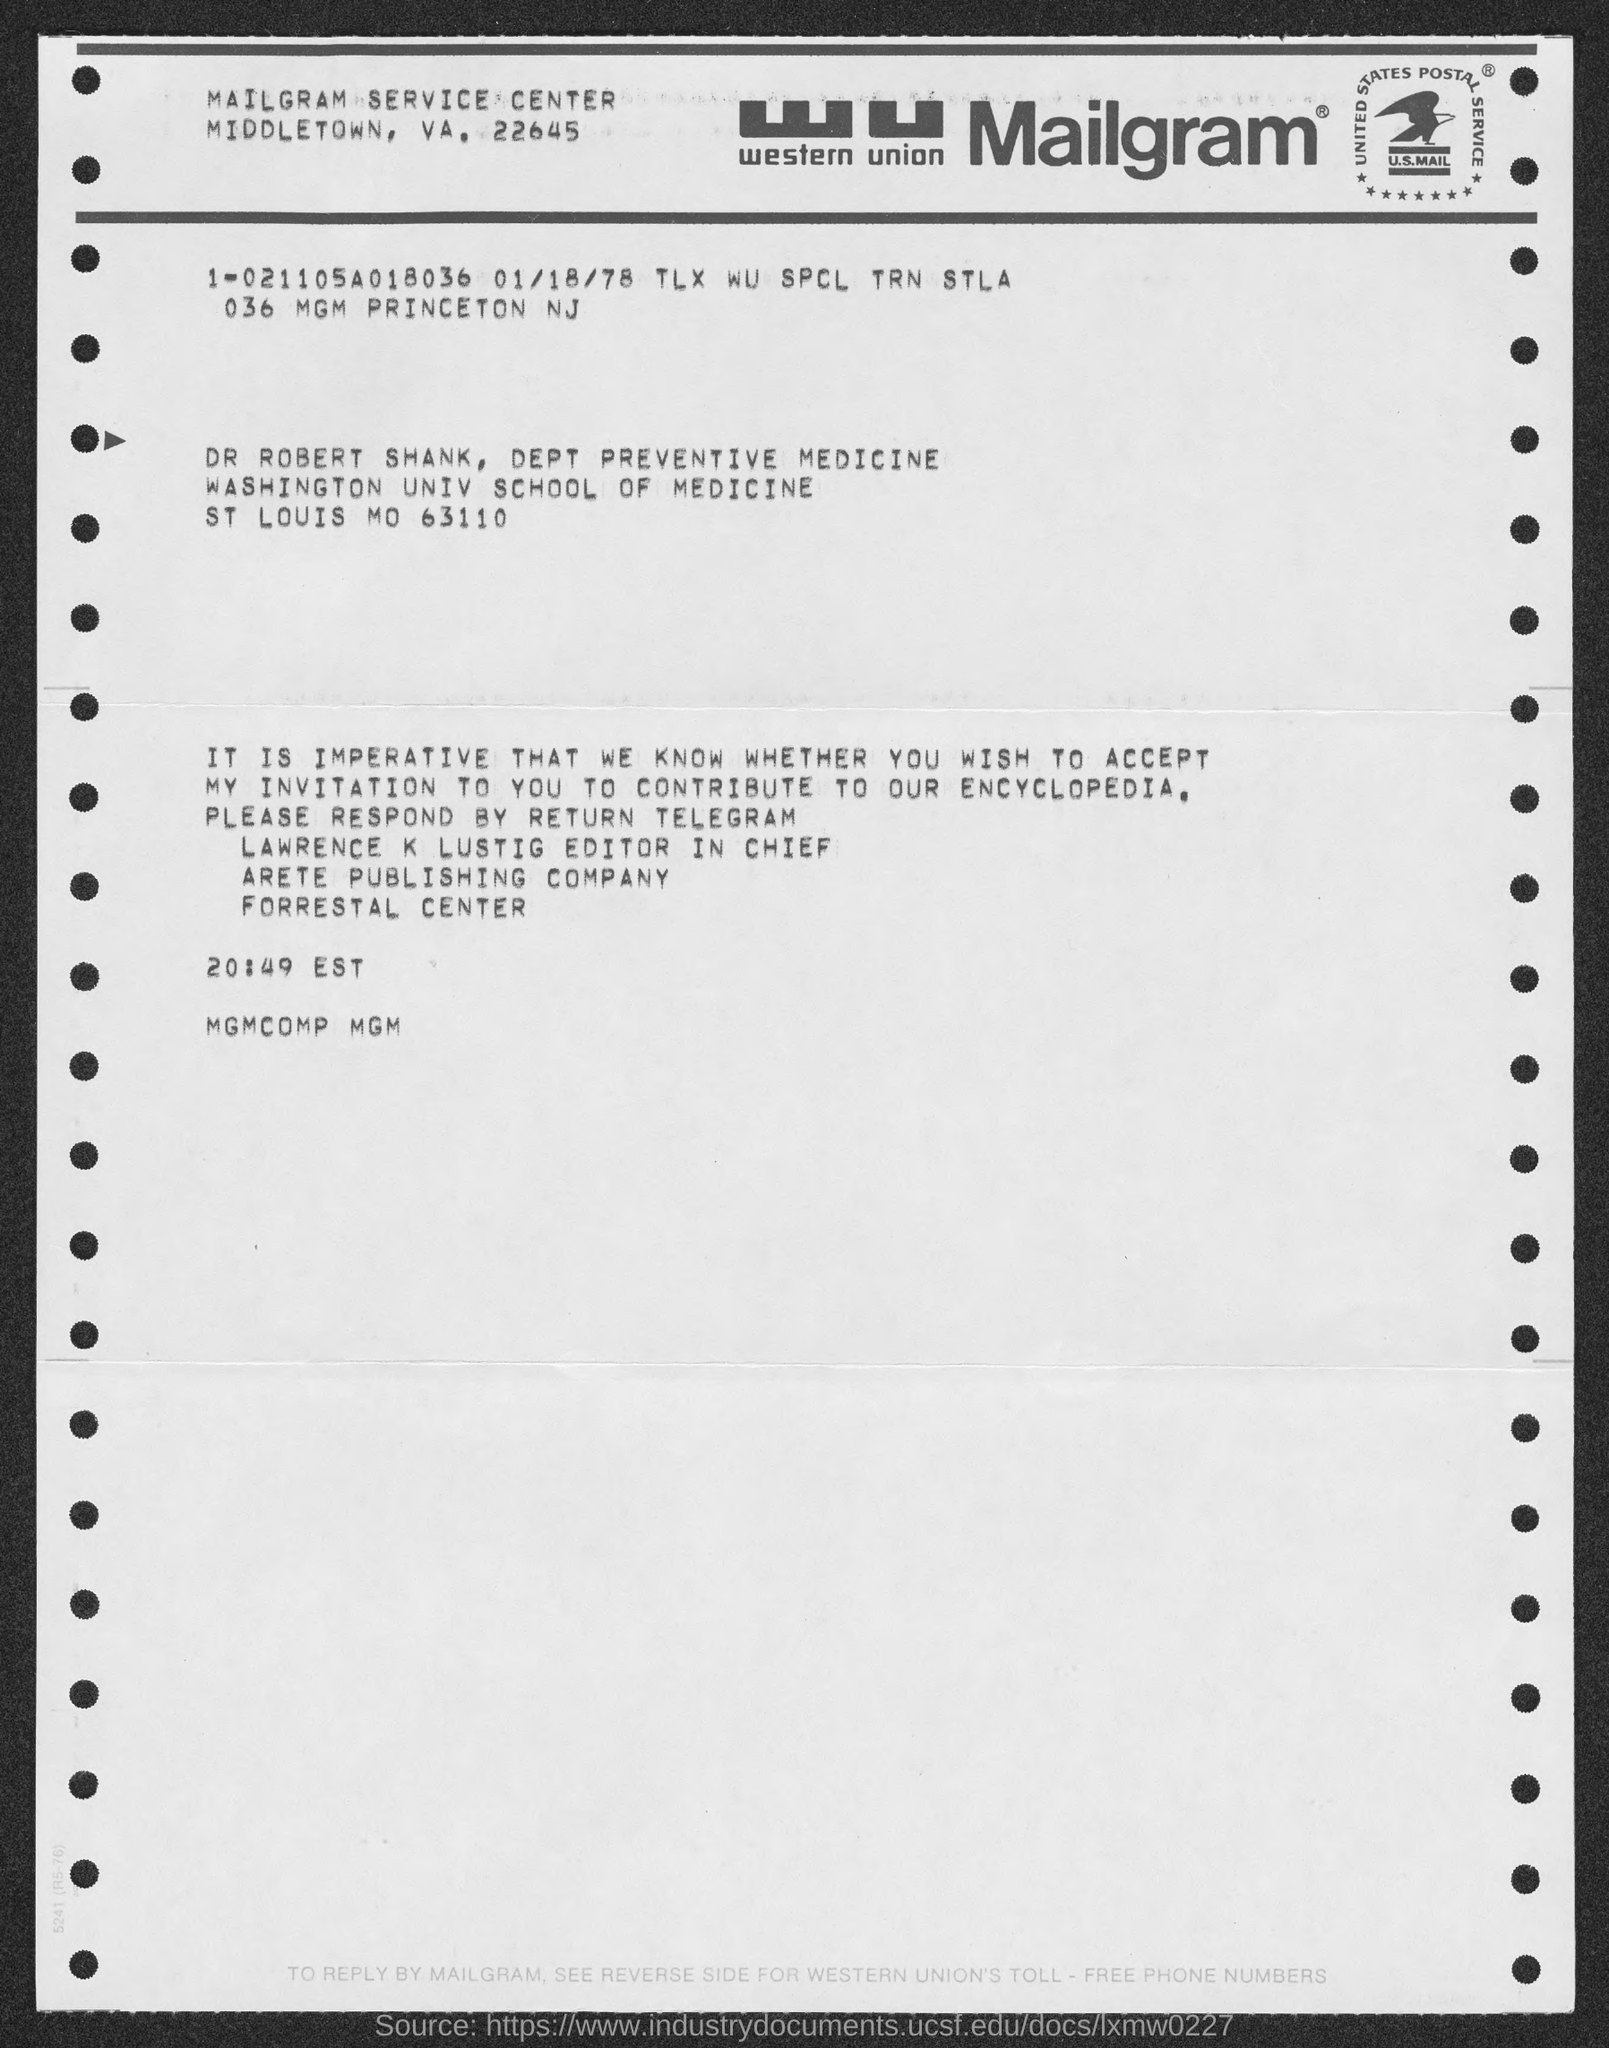List a handful of essential elements in this visual. The mailgram is addressed to Dr. Robert Shank. Lawrence is a part of Arete Publishing Company. It has been determined that Lawrence K Lustig is the editor in chief. 